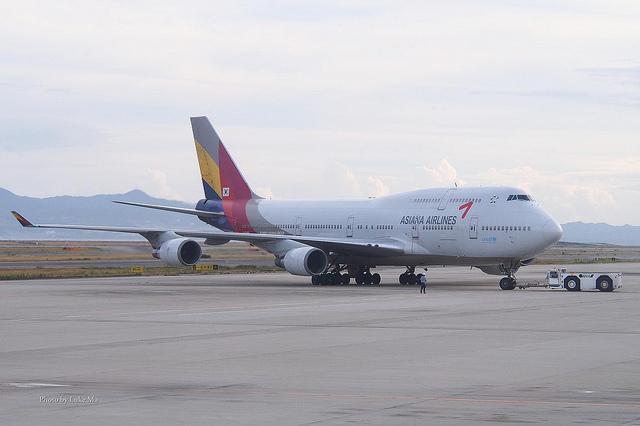Is this plane landing?
Short answer required. No. Is anyone walking near the plane?
Be succinct. Yes. Would a person use this form of transportation to go to the grocery store?
Concise answer only. No. Are there service vehicles?
Write a very short answer. No. Where is the train going?
Be succinct. No train. How many planes at the runways?
Be succinct. 1. Are there any buildings in the background?
Keep it brief. No. What is the number on the plane?
Answer briefly. 7. 